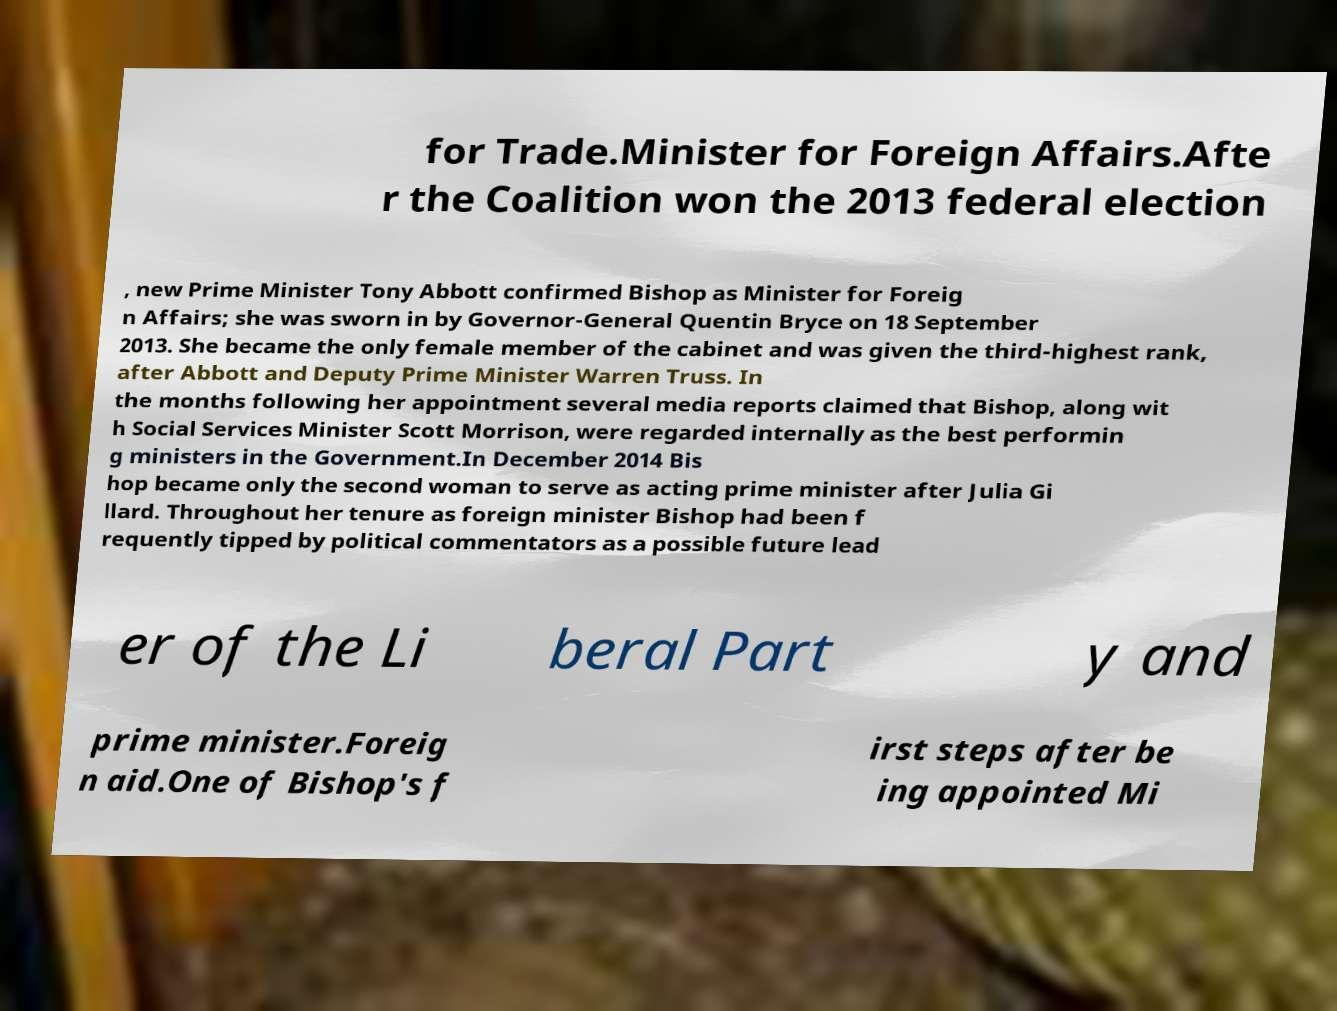Can you accurately transcribe the text from the provided image for me? for Trade.Minister for Foreign Affairs.Afte r the Coalition won the 2013 federal election , new Prime Minister Tony Abbott confirmed Bishop as Minister for Foreig n Affairs; she was sworn in by Governor-General Quentin Bryce on 18 September 2013. She became the only female member of the cabinet and was given the third-highest rank, after Abbott and Deputy Prime Minister Warren Truss. In the months following her appointment several media reports claimed that Bishop, along wit h Social Services Minister Scott Morrison, were regarded internally as the best performin g ministers in the Government.In December 2014 Bis hop became only the second woman to serve as acting prime minister after Julia Gi llard. Throughout her tenure as foreign minister Bishop had been f requently tipped by political commentators as a possible future lead er of the Li beral Part y and prime minister.Foreig n aid.One of Bishop's f irst steps after be ing appointed Mi 